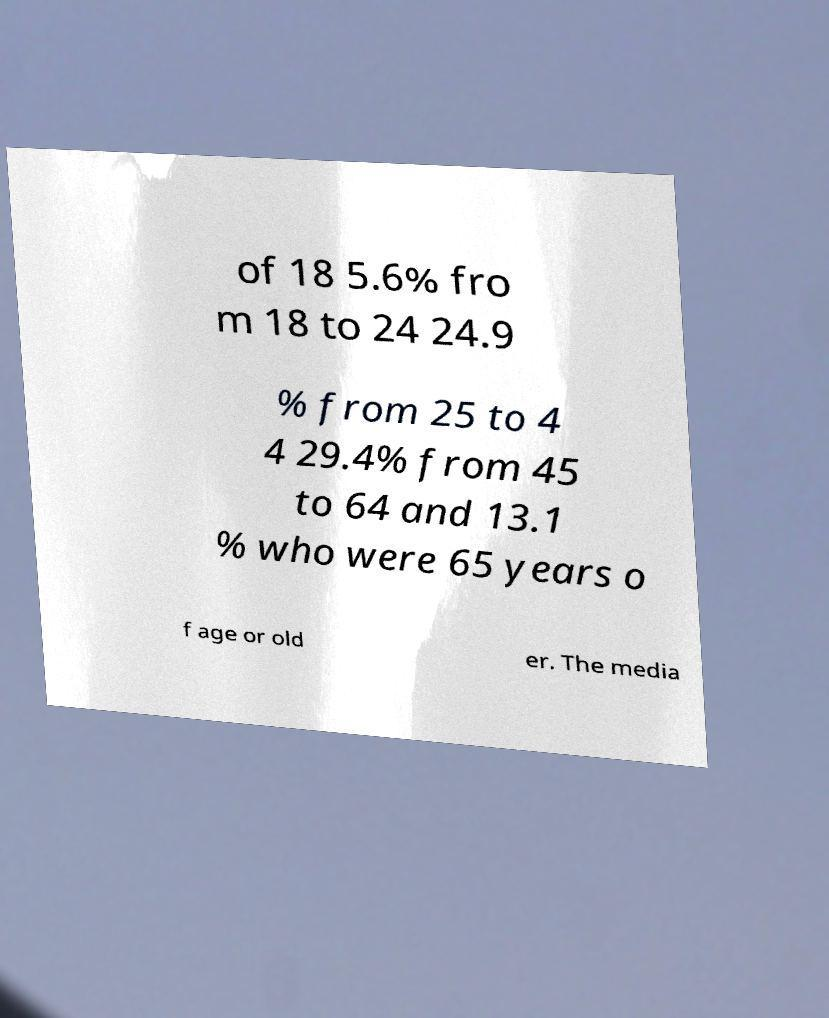Could you extract and type out the text from this image? of 18 5.6% fro m 18 to 24 24.9 % from 25 to 4 4 29.4% from 45 to 64 and 13.1 % who were 65 years o f age or old er. The media 